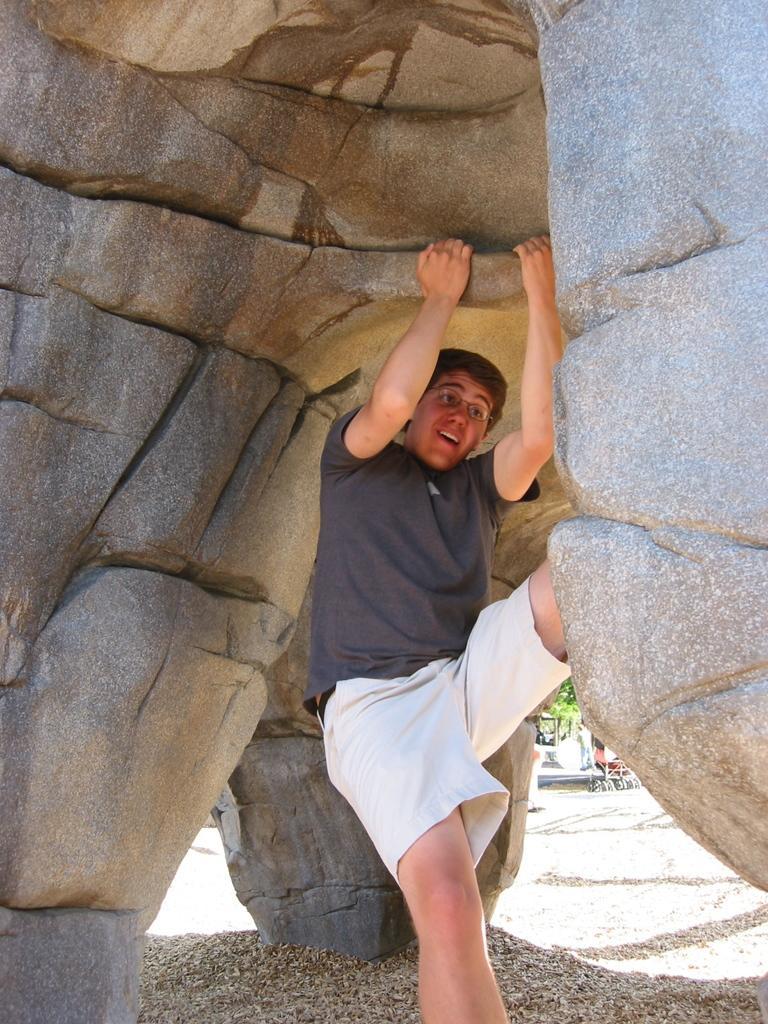Can you describe this image briefly? In this picture we can see one person is hanging with the help of rock. 